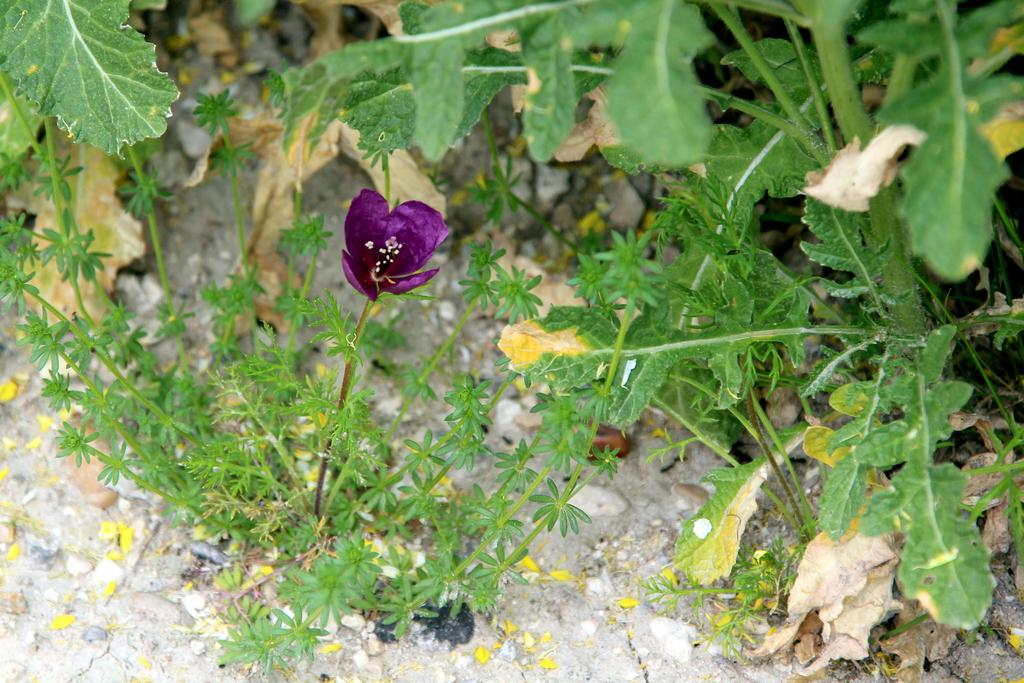What type of flower is in the image? There is a purple flower in the image. How is the flower attached to the plant? The flower is on the stem of a plant. What can be seen around the flower? There are many plants surrounding the flower. What type of pail is being used to collect payment near the dock in the image? There is no pail, payment, or dock present in the image; it only features a purple flower on a plant surrounded by other plants. 